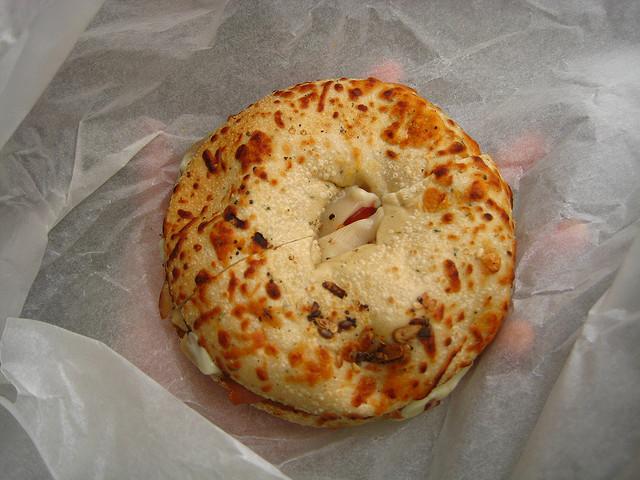Is the bread in one piece?
Answer briefly. No. What is inside the bread?
Short answer required. Cheese. What's under the paper?
Concise answer only. Hand. 